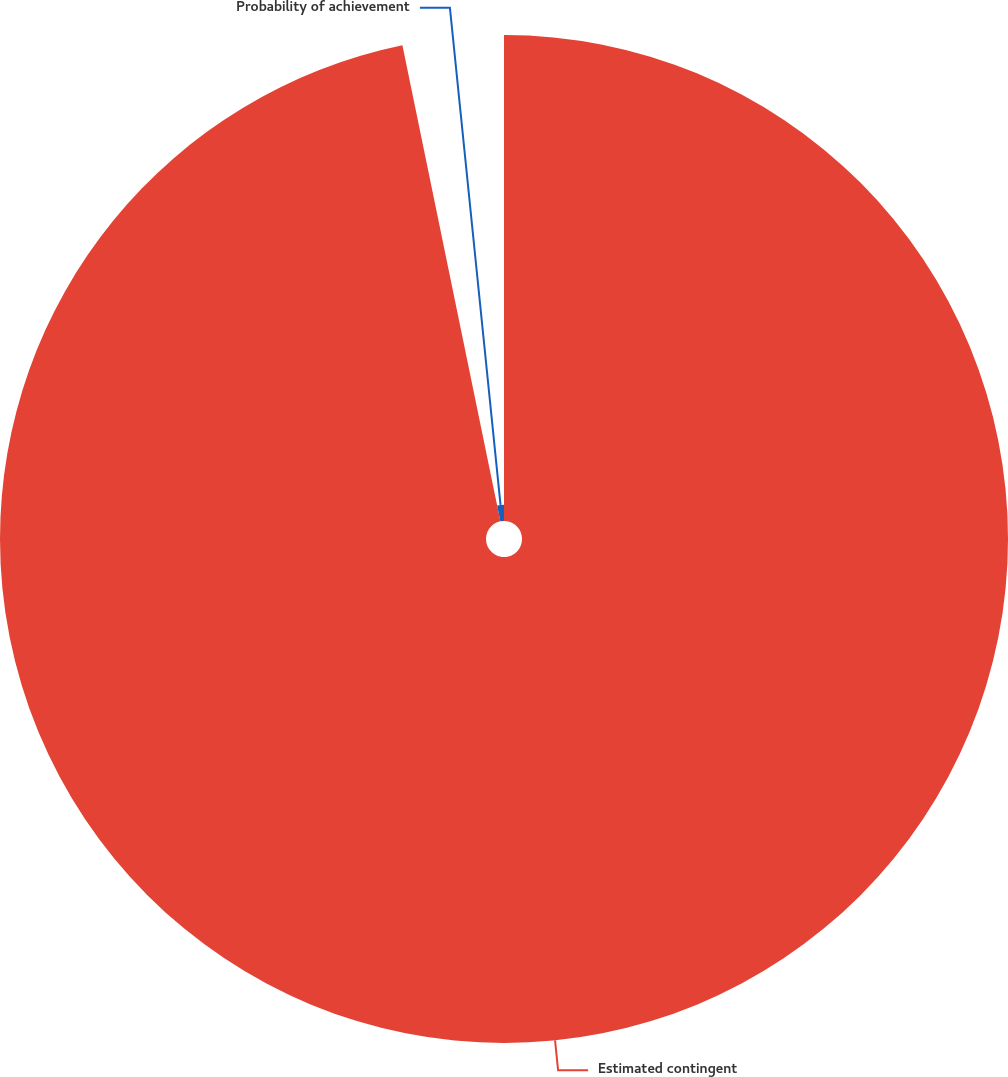<chart> <loc_0><loc_0><loc_500><loc_500><pie_chart><fcel>Estimated contingent<fcel>Probability of achievement<nl><fcel>96.77%<fcel>3.23%<nl></chart> 